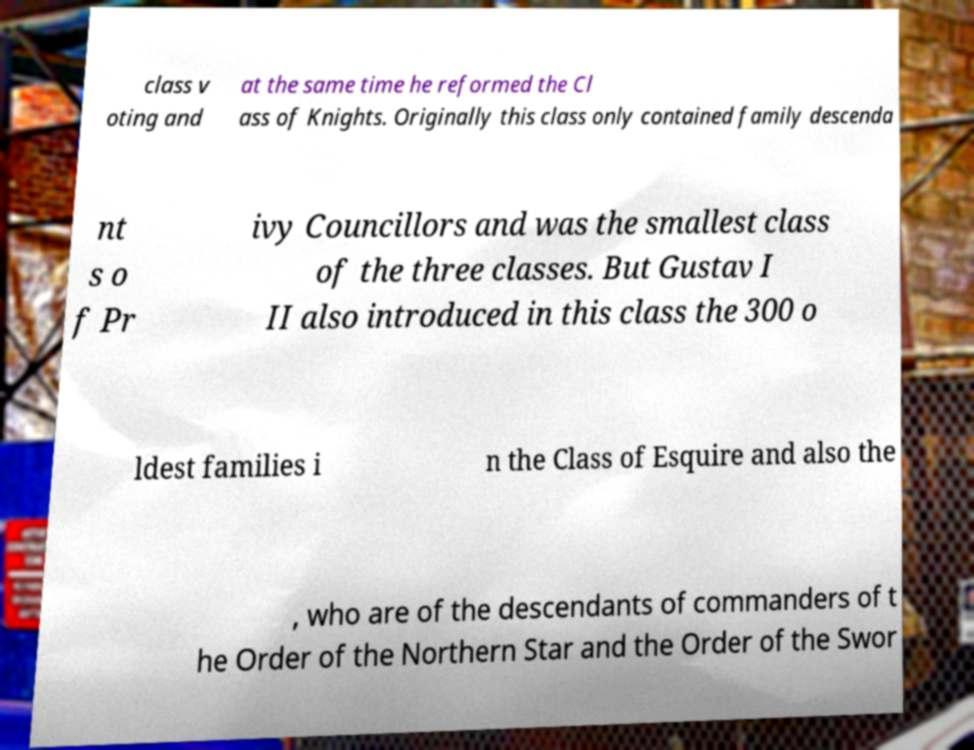There's text embedded in this image that I need extracted. Can you transcribe it verbatim? class v oting and at the same time he reformed the Cl ass of Knights. Originally this class only contained family descenda nt s o f Pr ivy Councillors and was the smallest class of the three classes. But Gustav I II also introduced in this class the 300 o ldest families i n the Class of Esquire and also the , who are of the descendants of commanders of t he Order of the Northern Star and the Order of the Swor 